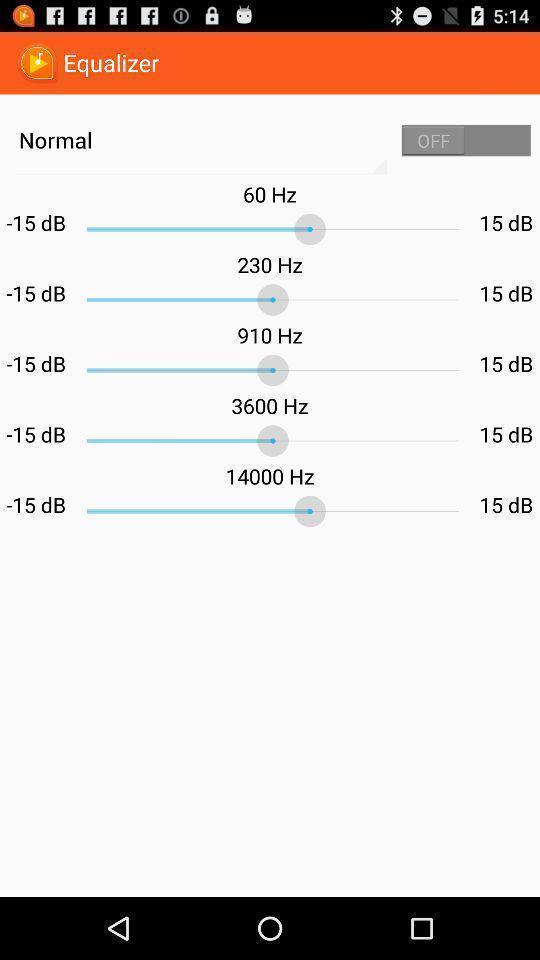Describe the key features of this screenshot. Settings option for a sound system. 